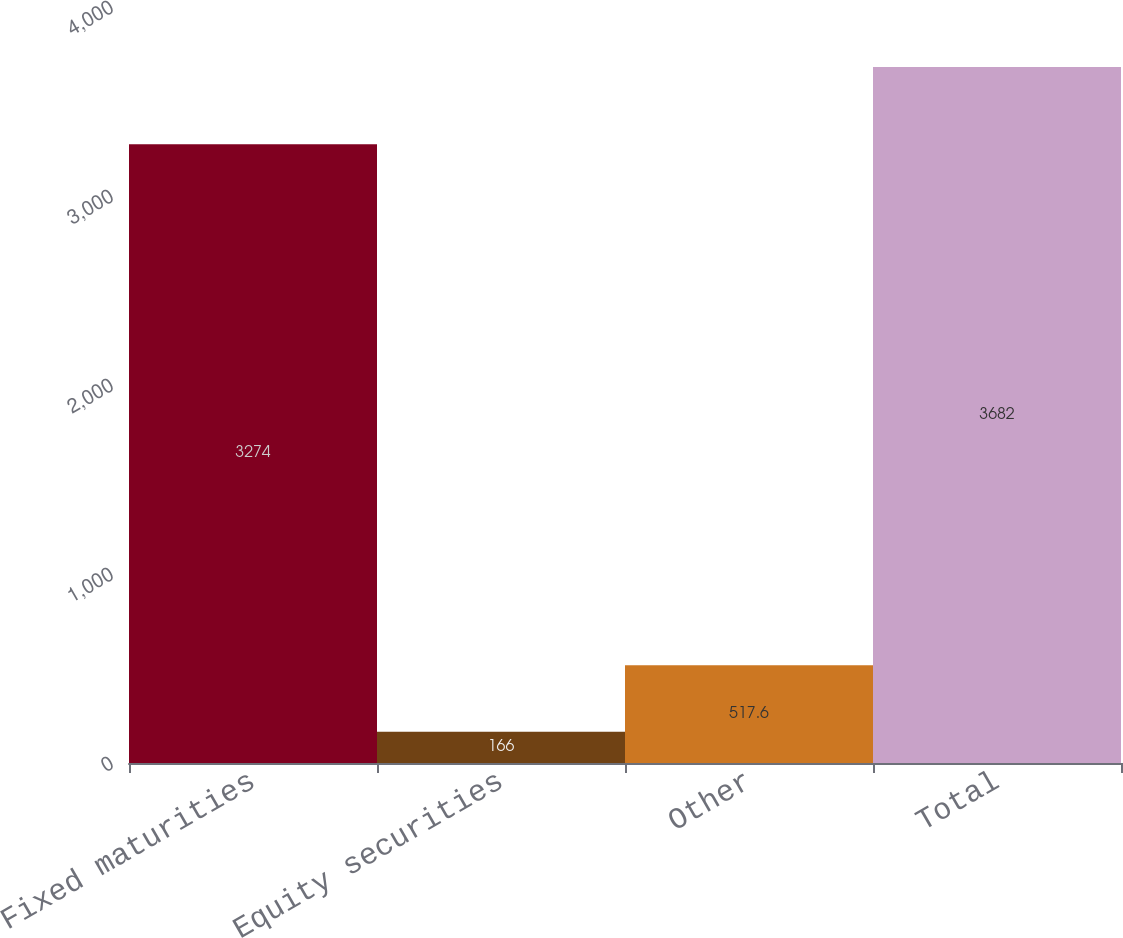Convert chart. <chart><loc_0><loc_0><loc_500><loc_500><bar_chart><fcel>Fixed maturities<fcel>Equity securities<fcel>Other<fcel>Total<nl><fcel>3274<fcel>166<fcel>517.6<fcel>3682<nl></chart> 